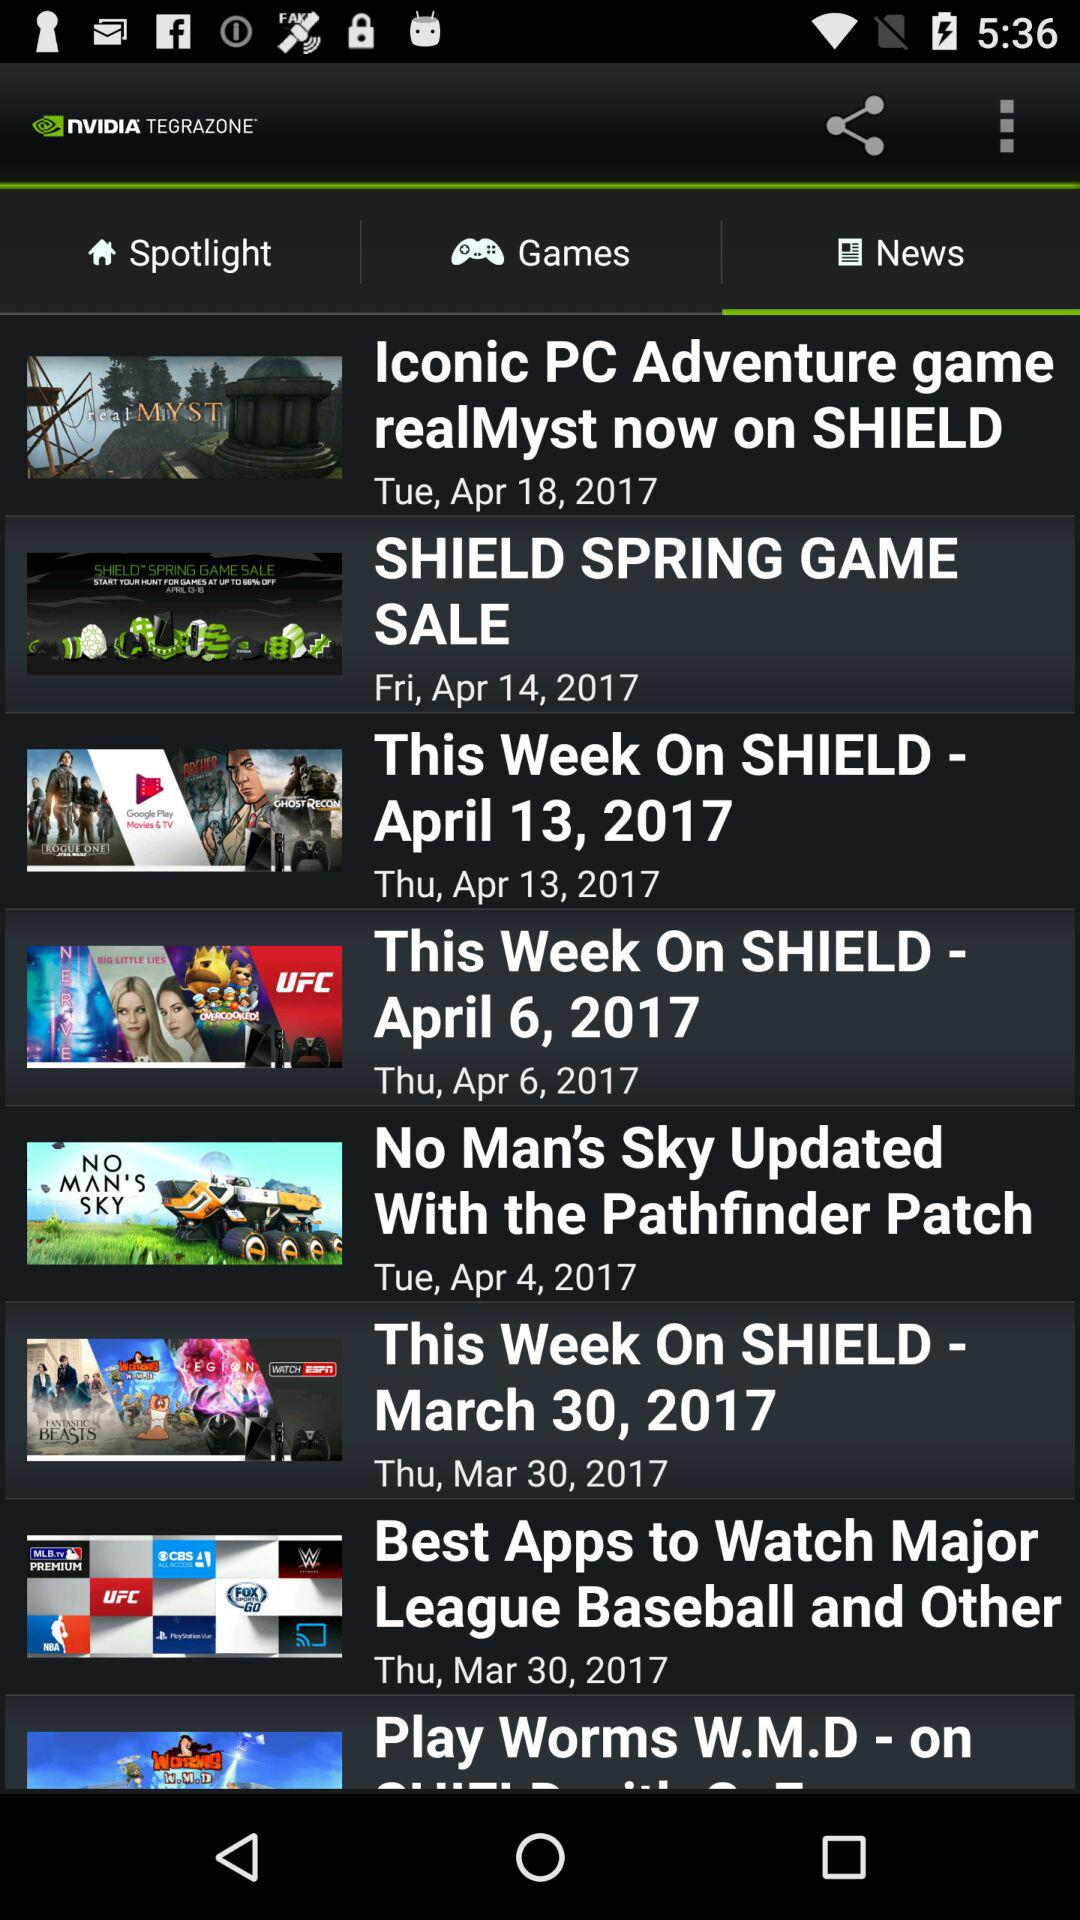What is the publication date of No Man's Sky? The publication date is Tuesday, April 4, 2017. 